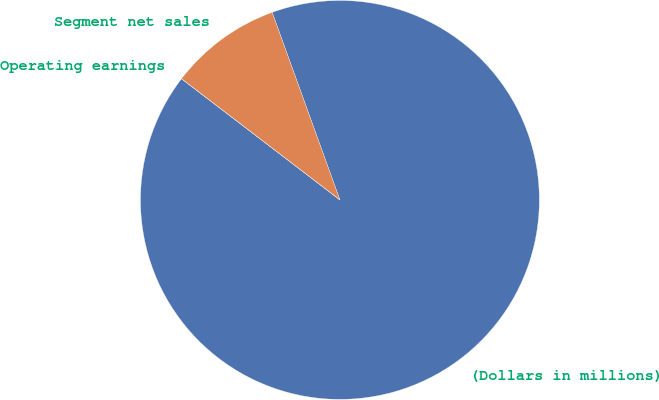Convert chart to OTSL. <chart><loc_0><loc_0><loc_500><loc_500><pie_chart><fcel>(Dollars in millions)<fcel>Segment net sales<fcel>Operating earnings<nl><fcel>90.91%<fcel>9.09%<fcel>0.0%<nl></chart> 